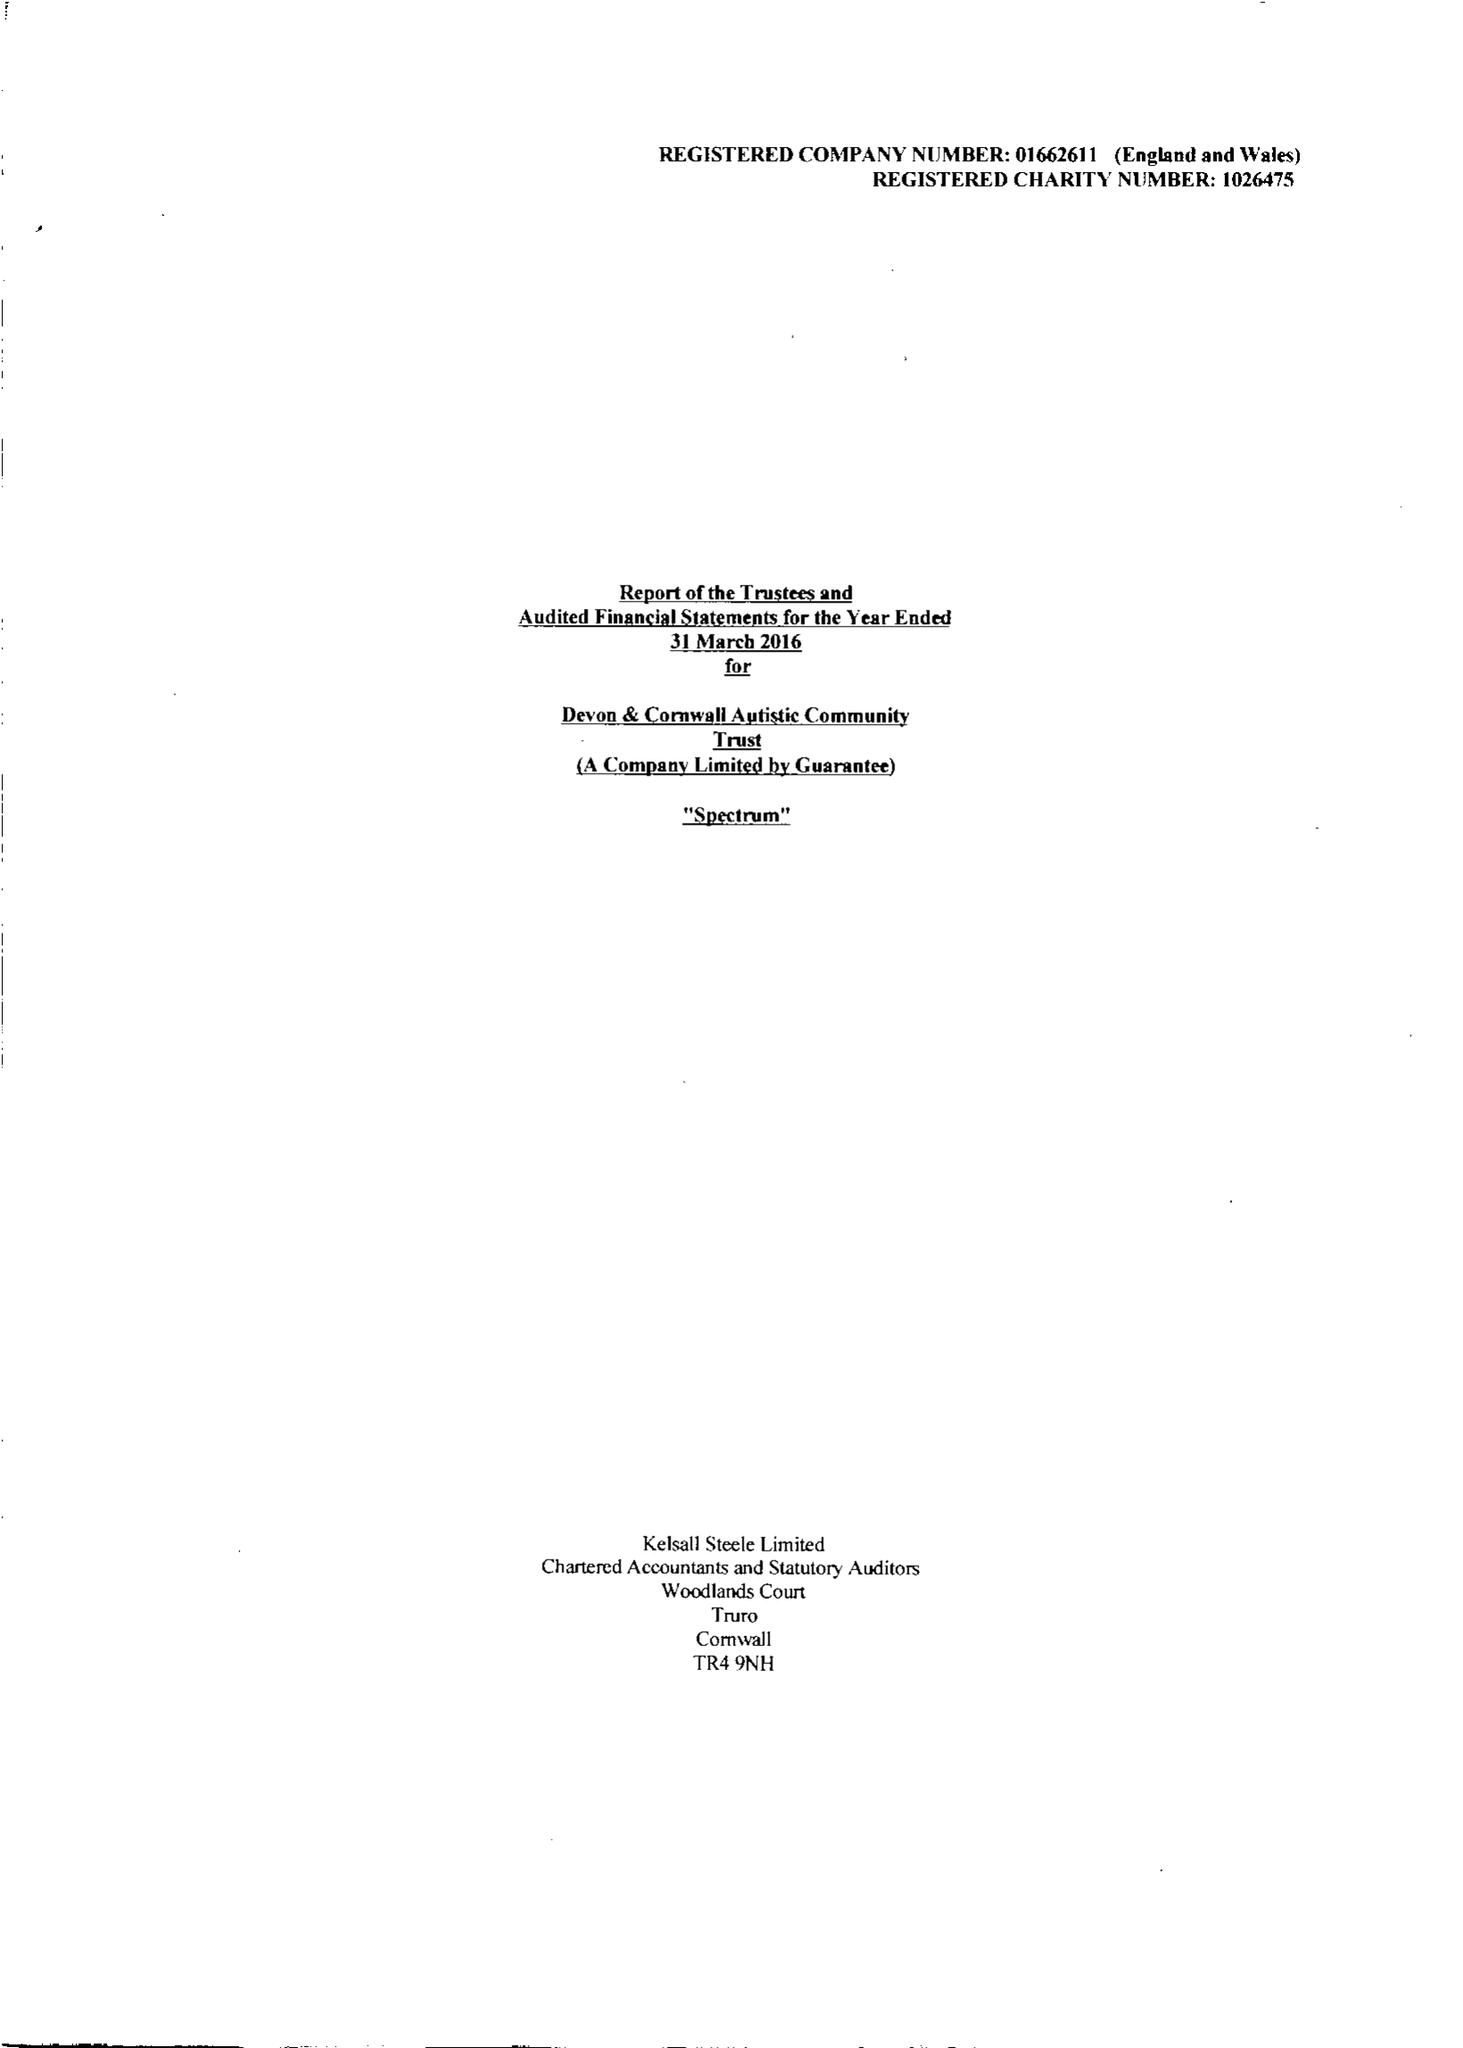What is the value for the spending_annually_in_british_pounds?
Answer the question using a single word or phrase. 10741330.00 